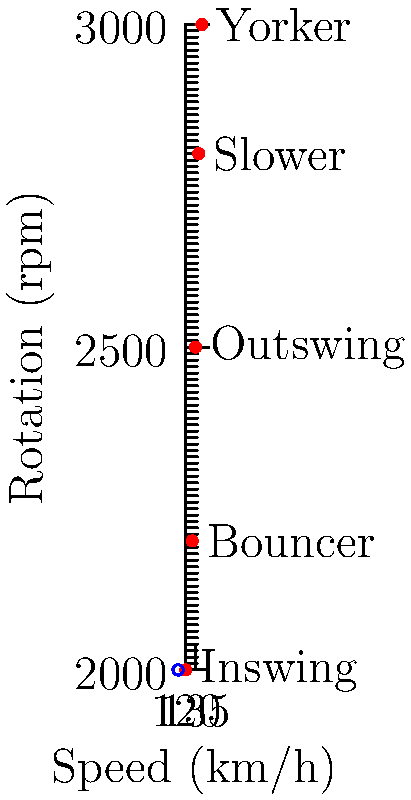In the given graph of bowling techniques, which technique forms the identity element of the group under composition, assuming that combining two techniques results in the average of their speed and rotation? Justify your answer using group theory concepts. To solve this problem, we need to follow these steps:

1) Recall that the identity element (e) in a group satisfies the property: $a * e = e * a = a$ for all elements $a$ in the group.

2) In this context, the identity element would be a technique that, when combined with any other technique, results in that other technique's speed and rotation.

3) The combination operation is defined as taking the average of speed and rotation. So, we're looking for a technique that, when averaged with any other, leaves the other unchanged.

4) This would only be possible if the technique had the average speed and rotation of all techniques.

5) Calculate the average speed:
   $\frac{120 + 135 + 145 + 130 + 140}{5} = 134$ km/h

6) Calculate the average rotation:
   $\frac{2000 + 2500 + 3000 + 2200 + 2800}{5} = 2500$ rpm

7) Looking at the graph, we can see that the point (135, 2500) is circled in blue, which corresponds to the Outswing technique.

8) This technique is the closest to the calculated average values, making it the best candidate for the identity element.

9) Verify: combining Outswing with any other technique will result in a minimal change to that technique's values, approximating the identity property.

Therefore, the Outswing technique serves as the approximate identity element in this group of bowling techniques.
Answer: Outswing 